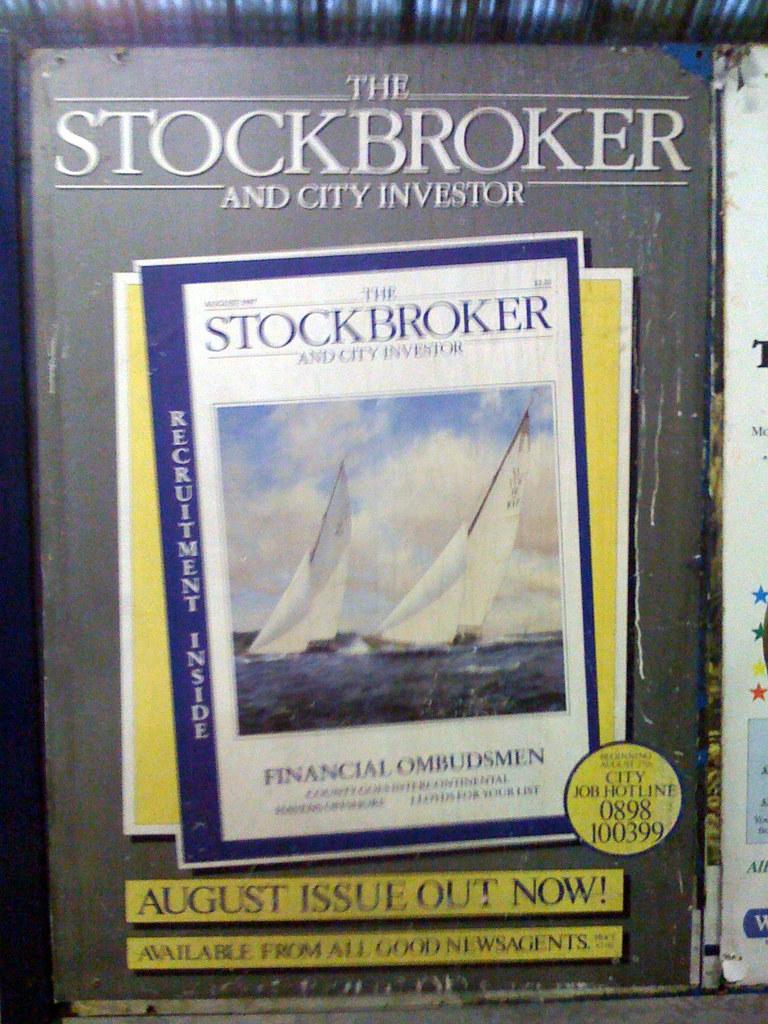What month is cited as having an issue out now?
Your response must be concise. August. 